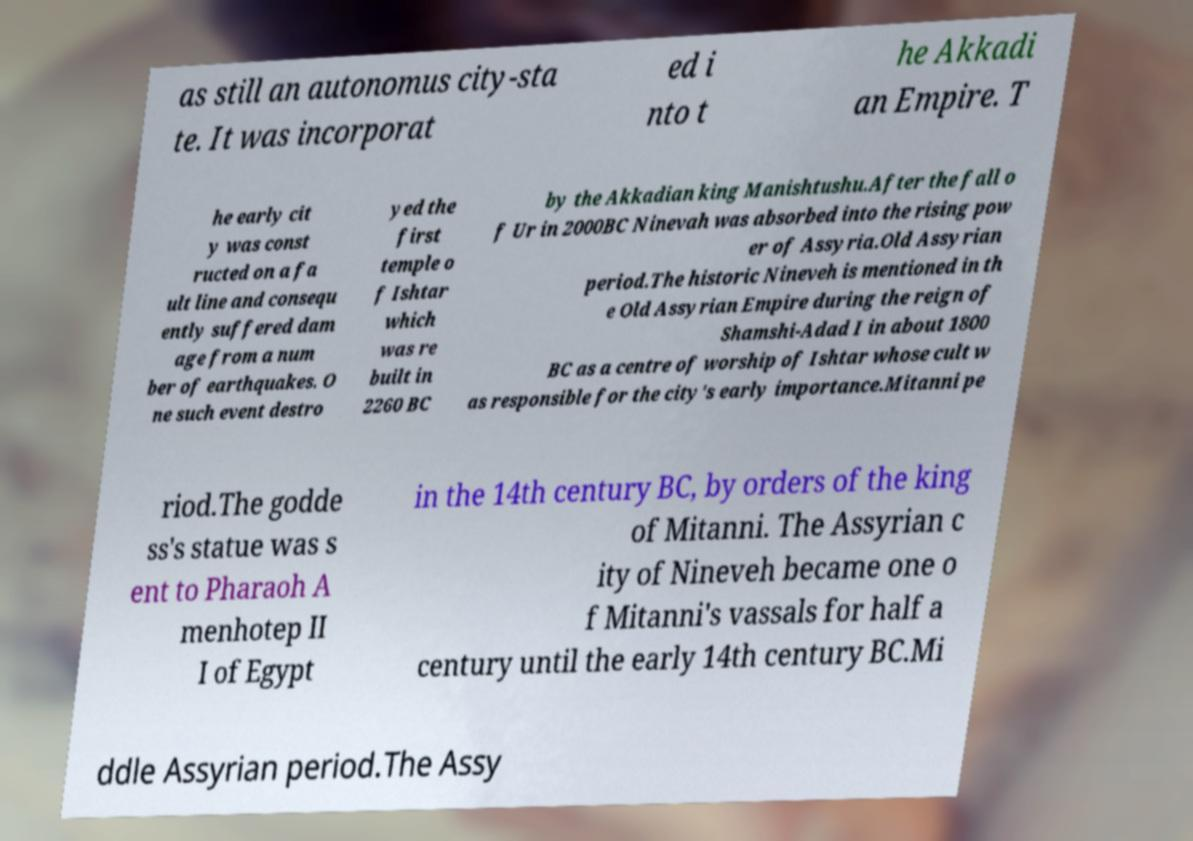For documentation purposes, I need the text within this image transcribed. Could you provide that? as still an autonomus city-sta te. It was incorporat ed i nto t he Akkadi an Empire. T he early cit y was const ructed on a fa ult line and consequ ently suffered dam age from a num ber of earthquakes. O ne such event destro yed the first temple o f Ishtar which was re built in 2260 BC by the Akkadian king Manishtushu.After the fall o f Ur in 2000BC Ninevah was absorbed into the rising pow er of Assyria.Old Assyrian period.The historic Nineveh is mentioned in th e Old Assyrian Empire during the reign of Shamshi-Adad I in about 1800 BC as a centre of worship of Ishtar whose cult w as responsible for the city's early importance.Mitanni pe riod.The godde ss's statue was s ent to Pharaoh A menhotep II I of Egypt in the 14th century BC, by orders of the king of Mitanni. The Assyrian c ity of Nineveh became one o f Mitanni's vassals for half a century until the early 14th century BC.Mi ddle Assyrian period.The Assy 